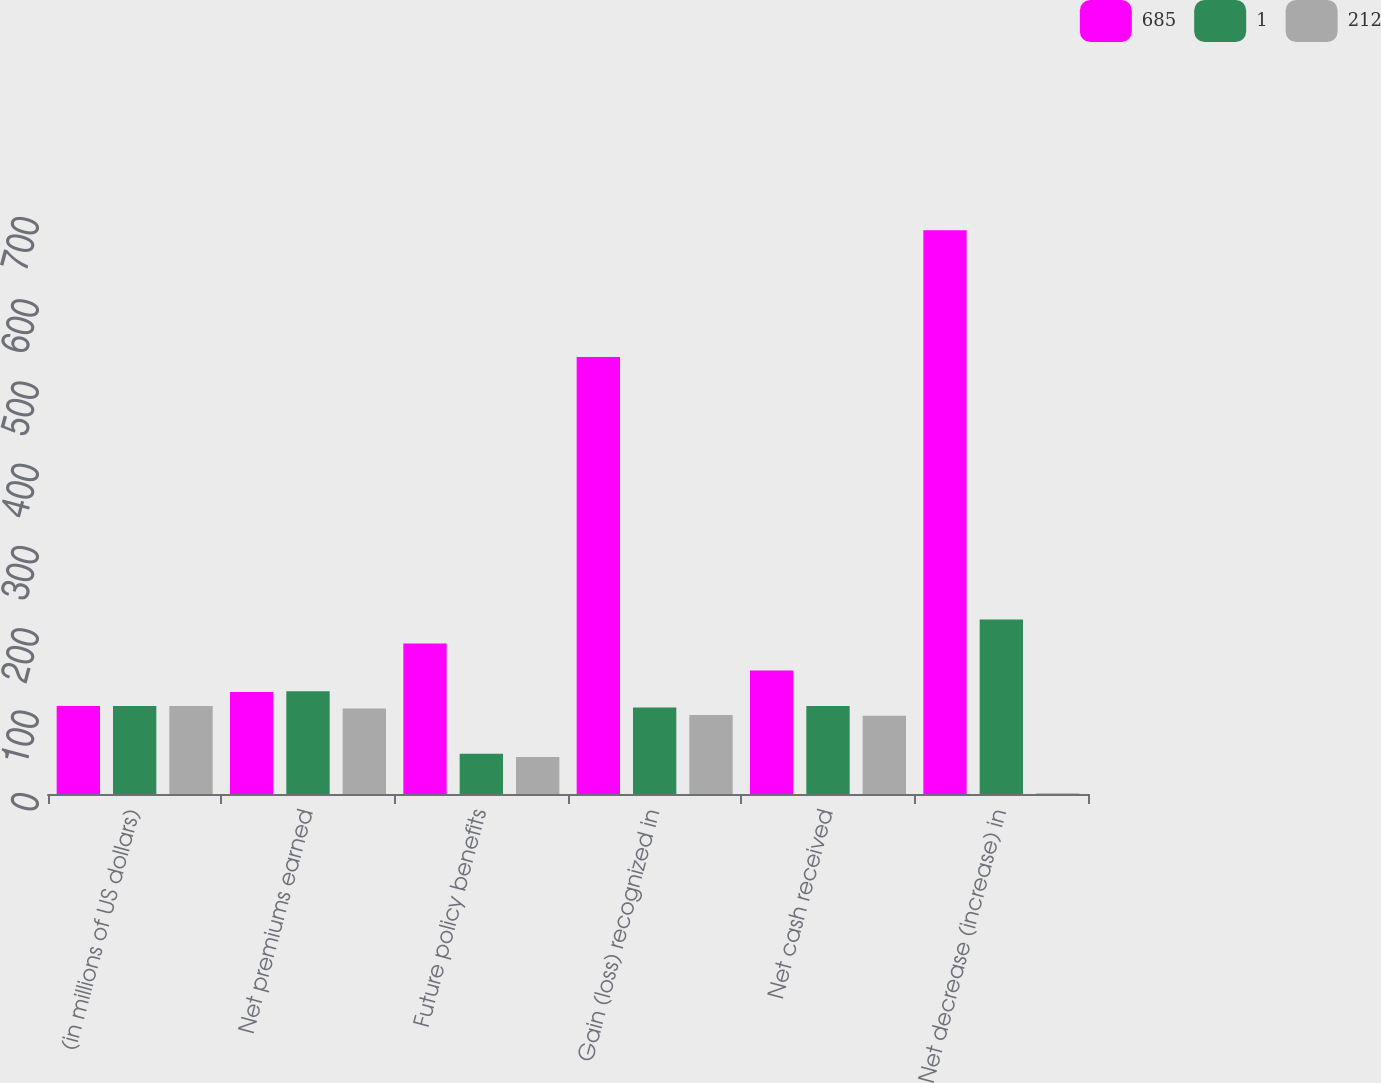<chart> <loc_0><loc_0><loc_500><loc_500><stacked_bar_chart><ecel><fcel>(in millions of US dollars)<fcel>Net premiums earned<fcel>Future policy benefits<fcel>Gain (loss) recognized in<fcel>Net cash received<fcel>Net decrease (increase) in<nl><fcel>685<fcel>107<fcel>124<fcel>183<fcel>531<fcel>150<fcel>685<nl><fcel>1<fcel>107<fcel>125<fcel>49<fcel>105<fcel>107<fcel>212<nl><fcel>212<fcel>107<fcel>104<fcel>45<fcel>96<fcel>95<fcel>1<nl></chart> 